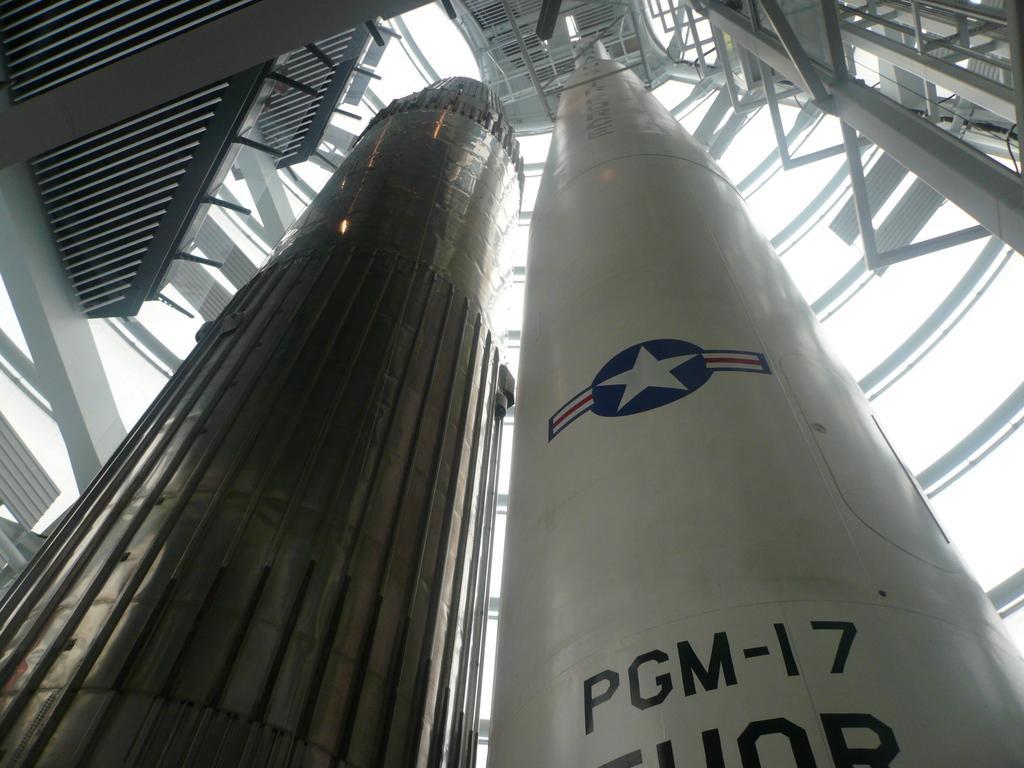Describe this image in one or two sentences. In this image, we can see missiles and in the background, there are rods and there is some text on one of the missiles. 